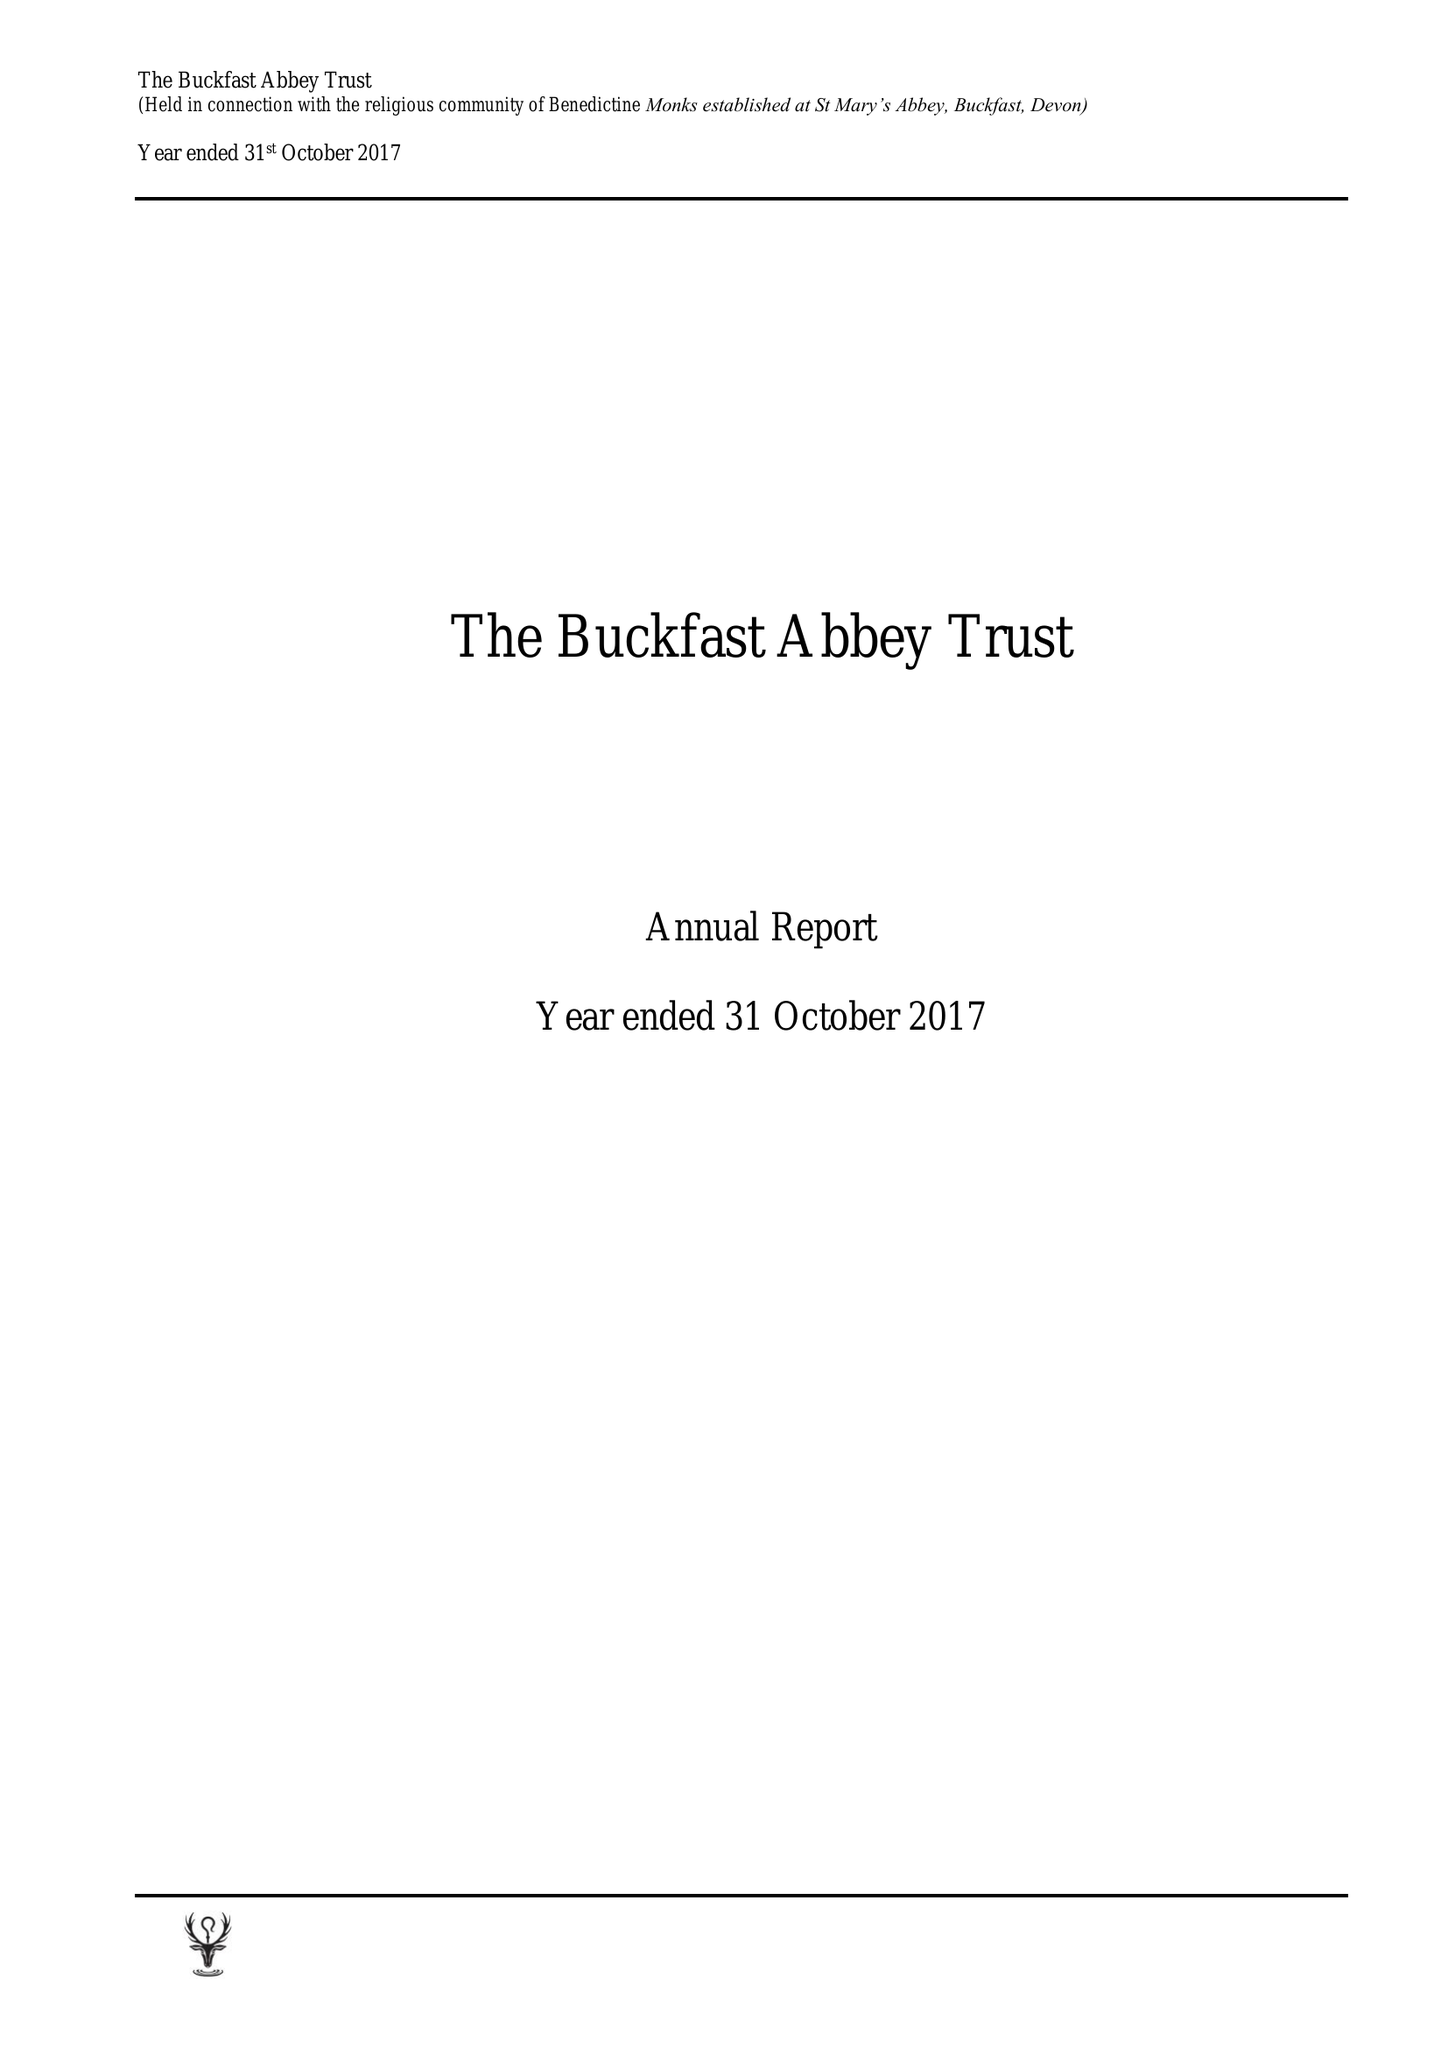What is the value for the income_annually_in_british_pounds?
Answer the question using a single word or phrase. 10880405.00 